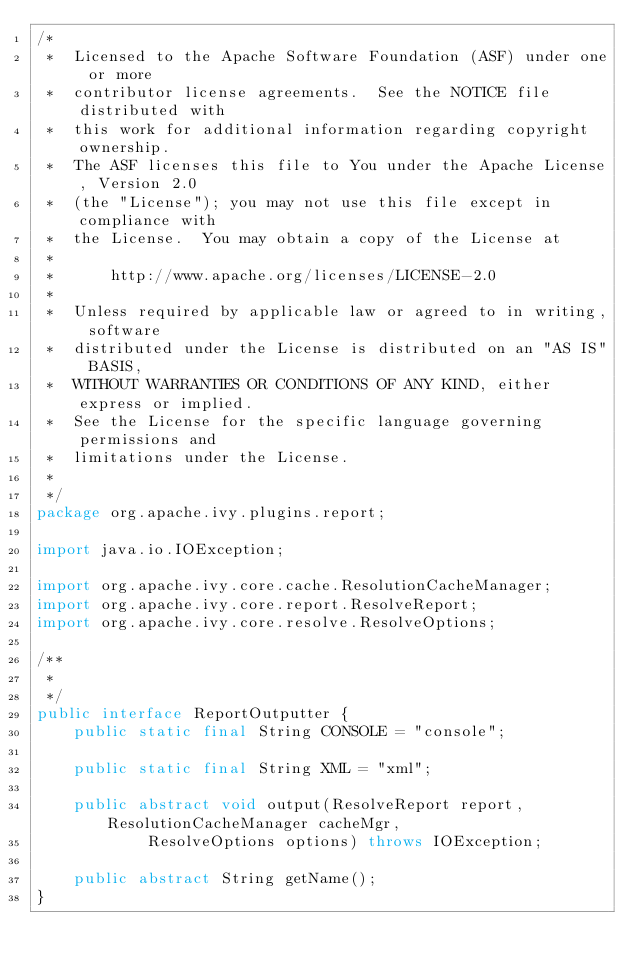Convert code to text. <code><loc_0><loc_0><loc_500><loc_500><_Java_>/*
 *  Licensed to the Apache Software Foundation (ASF) under one or more
 *  contributor license agreements.  See the NOTICE file distributed with
 *  this work for additional information regarding copyright ownership.
 *  The ASF licenses this file to You under the Apache License, Version 2.0
 *  (the "License"); you may not use this file except in compliance with
 *  the License.  You may obtain a copy of the License at
 *
 *      http://www.apache.org/licenses/LICENSE-2.0
 *
 *  Unless required by applicable law or agreed to in writing, software
 *  distributed under the License is distributed on an "AS IS" BASIS,
 *  WITHOUT WARRANTIES OR CONDITIONS OF ANY KIND, either express or implied.
 *  See the License for the specific language governing permissions and
 *  limitations under the License.
 *
 */
package org.apache.ivy.plugins.report;

import java.io.IOException;

import org.apache.ivy.core.cache.ResolutionCacheManager;
import org.apache.ivy.core.report.ResolveReport;
import org.apache.ivy.core.resolve.ResolveOptions;

/**
 *
 */
public interface ReportOutputter {
    public static final String CONSOLE = "console";

    public static final String XML = "xml";

    public abstract void output(ResolveReport report, ResolutionCacheManager cacheMgr,
            ResolveOptions options) throws IOException;

    public abstract String getName();
}
</code> 